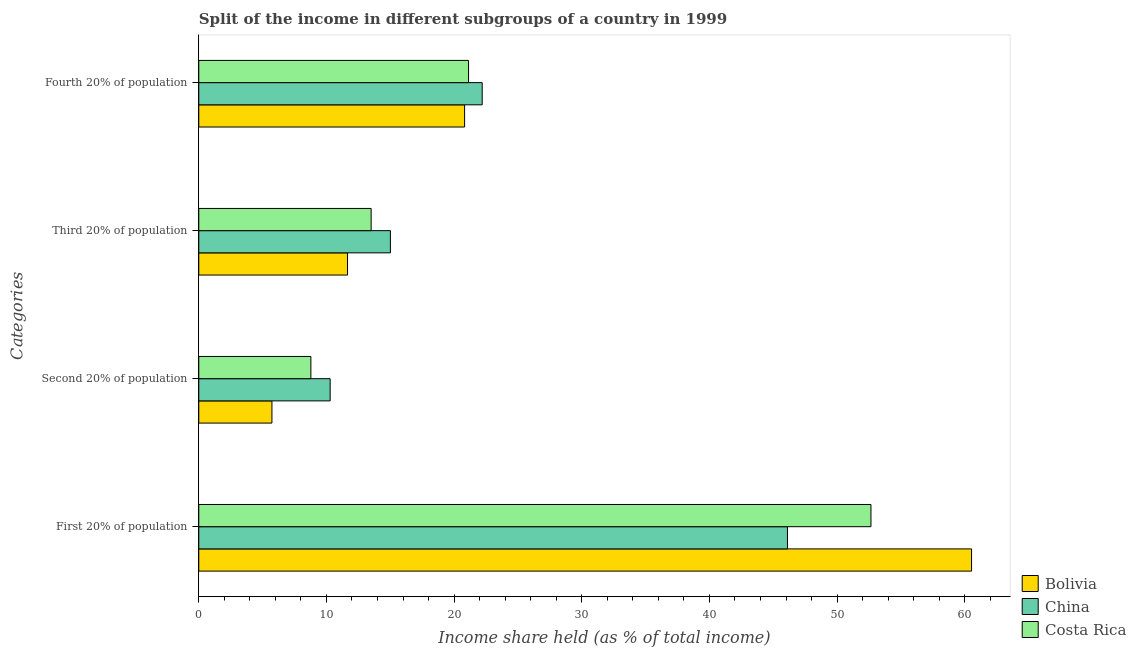How many groups of bars are there?
Keep it short and to the point. 4. Are the number of bars on each tick of the Y-axis equal?
Ensure brevity in your answer.  Yes. What is the label of the 1st group of bars from the top?
Provide a succinct answer. Fourth 20% of population. What is the share of the income held by second 20% of the population in Costa Rica?
Ensure brevity in your answer.  8.78. Across all countries, what is the maximum share of the income held by fourth 20% of the population?
Offer a very short reply. 22.2. Across all countries, what is the minimum share of the income held by fourth 20% of the population?
Your answer should be very brief. 20.82. In which country was the share of the income held by fourth 20% of the population minimum?
Ensure brevity in your answer.  Bolivia. What is the total share of the income held by fourth 20% of the population in the graph?
Provide a short and direct response. 64.15. What is the difference between the share of the income held by first 20% of the population in Costa Rica and that in China?
Your answer should be compact. 6.54. What is the difference between the share of the income held by fourth 20% of the population in Bolivia and the share of the income held by second 20% of the population in Costa Rica?
Provide a short and direct response. 12.04. What is the average share of the income held by first 20% of the population per country?
Offer a very short reply. 53.1. What is the difference between the share of the income held by fourth 20% of the population and share of the income held by second 20% of the population in Costa Rica?
Provide a succinct answer. 12.35. In how many countries, is the share of the income held by third 20% of the population greater than 42 %?
Keep it short and to the point. 0. What is the ratio of the share of the income held by fourth 20% of the population in Costa Rica to that in Bolivia?
Your response must be concise. 1.01. Is the share of the income held by fourth 20% of the population in Bolivia less than that in China?
Make the answer very short. Yes. What is the difference between the highest and the second highest share of the income held by second 20% of the population?
Ensure brevity in your answer.  1.51. What is the difference between the highest and the lowest share of the income held by first 20% of the population?
Offer a terse response. 14.42. Is the sum of the share of the income held by first 20% of the population in China and Costa Rica greater than the maximum share of the income held by fourth 20% of the population across all countries?
Ensure brevity in your answer.  Yes. Is it the case that in every country, the sum of the share of the income held by second 20% of the population and share of the income held by fourth 20% of the population is greater than the sum of share of the income held by first 20% of the population and share of the income held by third 20% of the population?
Give a very brief answer. No. Is it the case that in every country, the sum of the share of the income held by first 20% of the population and share of the income held by second 20% of the population is greater than the share of the income held by third 20% of the population?
Ensure brevity in your answer.  Yes. How many bars are there?
Give a very brief answer. 12. Are all the bars in the graph horizontal?
Your answer should be compact. Yes. How many countries are there in the graph?
Provide a succinct answer. 3. What is the difference between two consecutive major ticks on the X-axis?
Your response must be concise. 10. Are the values on the major ticks of X-axis written in scientific E-notation?
Provide a short and direct response. No. Where does the legend appear in the graph?
Your answer should be very brief. Bottom right. How many legend labels are there?
Give a very brief answer. 3. How are the legend labels stacked?
Give a very brief answer. Vertical. What is the title of the graph?
Make the answer very short. Split of the income in different subgroups of a country in 1999. What is the label or title of the X-axis?
Offer a terse response. Income share held (as % of total income). What is the label or title of the Y-axis?
Make the answer very short. Categories. What is the Income share held (as % of total income) of Bolivia in First 20% of population?
Make the answer very short. 60.53. What is the Income share held (as % of total income) of China in First 20% of population?
Provide a short and direct response. 46.11. What is the Income share held (as % of total income) in Costa Rica in First 20% of population?
Offer a very short reply. 52.65. What is the Income share held (as % of total income) in Bolivia in Second 20% of population?
Offer a terse response. 5.73. What is the Income share held (as % of total income) in China in Second 20% of population?
Offer a very short reply. 10.29. What is the Income share held (as % of total income) in Costa Rica in Second 20% of population?
Give a very brief answer. 8.78. What is the Income share held (as % of total income) of Bolivia in Third 20% of population?
Your response must be concise. 11.65. What is the Income share held (as % of total income) in China in Third 20% of population?
Ensure brevity in your answer.  15.01. What is the Income share held (as % of total income) in Costa Rica in Third 20% of population?
Offer a terse response. 13.5. What is the Income share held (as % of total income) in Bolivia in Fourth 20% of population?
Your response must be concise. 20.82. What is the Income share held (as % of total income) in China in Fourth 20% of population?
Your response must be concise. 22.2. What is the Income share held (as % of total income) in Costa Rica in Fourth 20% of population?
Your answer should be very brief. 21.13. Across all Categories, what is the maximum Income share held (as % of total income) of Bolivia?
Offer a very short reply. 60.53. Across all Categories, what is the maximum Income share held (as % of total income) of China?
Offer a terse response. 46.11. Across all Categories, what is the maximum Income share held (as % of total income) of Costa Rica?
Give a very brief answer. 52.65. Across all Categories, what is the minimum Income share held (as % of total income) of Bolivia?
Provide a succinct answer. 5.73. Across all Categories, what is the minimum Income share held (as % of total income) of China?
Provide a short and direct response. 10.29. Across all Categories, what is the minimum Income share held (as % of total income) of Costa Rica?
Your answer should be compact. 8.78. What is the total Income share held (as % of total income) of Bolivia in the graph?
Provide a short and direct response. 98.73. What is the total Income share held (as % of total income) of China in the graph?
Offer a terse response. 93.61. What is the total Income share held (as % of total income) of Costa Rica in the graph?
Make the answer very short. 96.06. What is the difference between the Income share held (as % of total income) in Bolivia in First 20% of population and that in Second 20% of population?
Your answer should be compact. 54.8. What is the difference between the Income share held (as % of total income) in China in First 20% of population and that in Second 20% of population?
Provide a short and direct response. 35.82. What is the difference between the Income share held (as % of total income) in Costa Rica in First 20% of population and that in Second 20% of population?
Make the answer very short. 43.87. What is the difference between the Income share held (as % of total income) of Bolivia in First 20% of population and that in Third 20% of population?
Keep it short and to the point. 48.88. What is the difference between the Income share held (as % of total income) in China in First 20% of population and that in Third 20% of population?
Provide a short and direct response. 31.1. What is the difference between the Income share held (as % of total income) in Costa Rica in First 20% of population and that in Third 20% of population?
Your answer should be very brief. 39.15. What is the difference between the Income share held (as % of total income) in Bolivia in First 20% of population and that in Fourth 20% of population?
Offer a terse response. 39.71. What is the difference between the Income share held (as % of total income) of China in First 20% of population and that in Fourth 20% of population?
Give a very brief answer. 23.91. What is the difference between the Income share held (as % of total income) of Costa Rica in First 20% of population and that in Fourth 20% of population?
Ensure brevity in your answer.  31.52. What is the difference between the Income share held (as % of total income) of Bolivia in Second 20% of population and that in Third 20% of population?
Keep it short and to the point. -5.92. What is the difference between the Income share held (as % of total income) in China in Second 20% of population and that in Third 20% of population?
Give a very brief answer. -4.72. What is the difference between the Income share held (as % of total income) of Costa Rica in Second 20% of population and that in Third 20% of population?
Keep it short and to the point. -4.72. What is the difference between the Income share held (as % of total income) in Bolivia in Second 20% of population and that in Fourth 20% of population?
Offer a very short reply. -15.09. What is the difference between the Income share held (as % of total income) in China in Second 20% of population and that in Fourth 20% of population?
Ensure brevity in your answer.  -11.91. What is the difference between the Income share held (as % of total income) in Costa Rica in Second 20% of population and that in Fourth 20% of population?
Your response must be concise. -12.35. What is the difference between the Income share held (as % of total income) in Bolivia in Third 20% of population and that in Fourth 20% of population?
Your answer should be compact. -9.17. What is the difference between the Income share held (as % of total income) in China in Third 20% of population and that in Fourth 20% of population?
Offer a very short reply. -7.19. What is the difference between the Income share held (as % of total income) in Costa Rica in Third 20% of population and that in Fourth 20% of population?
Give a very brief answer. -7.63. What is the difference between the Income share held (as % of total income) of Bolivia in First 20% of population and the Income share held (as % of total income) of China in Second 20% of population?
Your answer should be compact. 50.24. What is the difference between the Income share held (as % of total income) of Bolivia in First 20% of population and the Income share held (as % of total income) of Costa Rica in Second 20% of population?
Provide a short and direct response. 51.75. What is the difference between the Income share held (as % of total income) of China in First 20% of population and the Income share held (as % of total income) of Costa Rica in Second 20% of population?
Offer a very short reply. 37.33. What is the difference between the Income share held (as % of total income) in Bolivia in First 20% of population and the Income share held (as % of total income) in China in Third 20% of population?
Give a very brief answer. 45.52. What is the difference between the Income share held (as % of total income) of Bolivia in First 20% of population and the Income share held (as % of total income) of Costa Rica in Third 20% of population?
Offer a terse response. 47.03. What is the difference between the Income share held (as % of total income) in China in First 20% of population and the Income share held (as % of total income) in Costa Rica in Third 20% of population?
Give a very brief answer. 32.61. What is the difference between the Income share held (as % of total income) of Bolivia in First 20% of population and the Income share held (as % of total income) of China in Fourth 20% of population?
Offer a terse response. 38.33. What is the difference between the Income share held (as % of total income) in Bolivia in First 20% of population and the Income share held (as % of total income) in Costa Rica in Fourth 20% of population?
Your response must be concise. 39.4. What is the difference between the Income share held (as % of total income) of China in First 20% of population and the Income share held (as % of total income) of Costa Rica in Fourth 20% of population?
Provide a succinct answer. 24.98. What is the difference between the Income share held (as % of total income) of Bolivia in Second 20% of population and the Income share held (as % of total income) of China in Third 20% of population?
Offer a very short reply. -9.28. What is the difference between the Income share held (as % of total income) of Bolivia in Second 20% of population and the Income share held (as % of total income) of Costa Rica in Third 20% of population?
Give a very brief answer. -7.77. What is the difference between the Income share held (as % of total income) in China in Second 20% of population and the Income share held (as % of total income) in Costa Rica in Third 20% of population?
Provide a short and direct response. -3.21. What is the difference between the Income share held (as % of total income) of Bolivia in Second 20% of population and the Income share held (as % of total income) of China in Fourth 20% of population?
Your answer should be compact. -16.47. What is the difference between the Income share held (as % of total income) in Bolivia in Second 20% of population and the Income share held (as % of total income) in Costa Rica in Fourth 20% of population?
Your answer should be compact. -15.4. What is the difference between the Income share held (as % of total income) in China in Second 20% of population and the Income share held (as % of total income) in Costa Rica in Fourth 20% of population?
Your answer should be very brief. -10.84. What is the difference between the Income share held (as % of total income) of Bolivia in Third 20% of population and the Income share held (as % of total income) of China in Fourth 20% of population?
Provide a short and direct response. -10.55. What is the difference between the Income share held (as % of total income) of Bolivia in Third 20% of population and the Income share held (as % of total income) of Costa Rica in Fourth 20% of population?
Give a very brief answer. -9.48. What is the difference between the Income share held (as % of total income) in China in Third 20% of population and the Income share held (as % of total income) in Costa Rica in Fourth 20% of population?
Provide a succinct answer. -6.12. What is the average Income share held (as % of total income) of Bolivia per Categories?
Your response must be concise. 24.68. What is the average Income share held (as % of total income) in China per Categories?
Your response must be concise. 23.4. What is the average Income share held (as % of total income) of Costa Rica per Categories?
Make the answer very short. 24.02. What is the difference between the Income share held (as % of total income) of Bolivia and Income share held (as % of total income) of China in First 20% of population?
Your answer should be compact. 14.42. What is the difference between the Income share held (as % of total income) in Bolivia and Income share held (as % of total income) in Costa Rica in First 20% of population?
Your answer should be very brief. 7.88. What is the difference between the Income share held (as % of total income) in China and Income share held (as % of total income) in Costa Rica in First 20% of population?
Ensure brevity in your answer.  -6.54. What is the difference between the Income share held (as % of total income) of Bolivia and Income share held (as % of total income) of China in Second 20% of population?
Give a very brief answer. -4.56. What is the difference between the Income share held (as % of total income) of Bolivia and Income share held (as % of total income) of Costa Rica in Second 20% of population?
Offer a terse response. -3.05. What is the difference between the Income share held (as % of total income) of China and Income share held (as % of total income) of Costa Rica in Second 20% of population?
Offer a very short reply. 1.51. What is the difference between the Income share held (as % of total income) of Bolivia and Income share held (as % of total income) of China in Third 20% of population?
Provide a short and direct response. -3.36. What is the difference between the Income share held (as % of total income) of Bolivia and Income share held (as % of total income) of Costa Rica in Third 20% of population?
Your answer should be very brief. -1.85. What is the difference between the Income share held (as % of total income) of China and Income share held (as % of total income) of Costa Rica in Third 20% of population?
Your answer should be compact. 1.51. What is the difference between the Income share held (as % of total income) of Bolivia and Income share held (as % of total income) of China in Fourth 20% of population?
Make the answer very short. -1.38. What is the difference between the Income share held (as % of total income) in Bolivia and Income share held (as % of total income) in Costa Rica in Fourth 20% of population?
Your answer should be very brief. -0.31. What is the difference between the Income share held (as % of total income) of China and Income share held (as % of total income) of Costa Rica in Fourth 20% of population?
Offer a very short reply. 1.07. What is the ratio of the Income share held (as % of total income) of Bolivia in First 20% of population to that in Second 20% of population?
Ensure brevity in your answer.  10.56. What is the ratio of the Income share held (as % of total income) in China in First 20% of population to that in Second 20% of population?
Give a very brief answer. 4.48. What is the ratio of the Income share held (as % of total income) of Costa Rica in First 20% of population to that in Second 20% of population?
Give a very brief answer. 6. What is the ratio of the Income share held (as % of total income) of Bolivia in First 20% of population to that in Third 20% of population?
Offer a terse response. 5.2. What is the ratio of the Income share held (as % of total income) in China in First 20% of population to that in Third 20% of population?
Ensure brevity in your answer.  3.07. What is the ratio of the Income share held (as % of total income) in Costa Rica in First 20% of population to that in Third 20% of population?
Your answer should be compact. 3.9. What is the ratio of the Income share held (as % of total income) in Bolivia in First 20% of population to that in Fourth 20% of population?
Your answer should be compact. 2.91. What is the ratio of the Income share held (as % of total income) in China in First 20% of population to that in Fourth 20% of population?
Offer a very short reply. 2.08. What is the ratio of the Income share held (as % of total income) of Costa Rica in First 20% of population to that in Fourth 20% of population?
Provide a short and direct response. 2.49. What is the ratio of the Income share held (as % of total income) in Bolivia in Second 20% of population to that in Third 20% of population?
Give a very brief answer. 0.49. What is the ratio of the Income share held (as % of total income) of China in Second 20% of population to that in Third 20% of population?
Provide a short and direct response. 0.69. What is the ratio of the Income share held (as % of total income) in Costa Rica in Second 20% of population to that in Third 20% of population?
Provide a succinct answer. 0.65. What is the ratio of the Income share held (as % of total income) in Bolivia in Second 20% of population to that in Fourth 20% of population?
Make the answer very short. 0.28. What is the ratio of the Income share held (as % of total income) of China in Second 20% of population to that in Fourth 20% of population?
Your response must be concise. 0.46. What is the ratio of the Income share held (as % of total income) of Costa Rica in Second 20% of population to that in Fourth 20% of population?
Make the answer very short. 0.42. What is the ratio of the Income share held (as % of total income) in Bolivia in Third 20% of population to that in Fourth 20% of population?
Provide a succinct answer. 0.56. What is the ratio of the Income share held (as % of total income) of China in Third 20% of population to that in Fourth 20% of population?
Give a very brief answer. 0.68. What is the ratio of the Income share held (as % of total income) of Costa Rica in Third 20% of population to that in Fourth 20% of population?
Ensure brevity in your answer.  0.64. What is the difference between the highest and the second highest Income share held (as % of total income) of Bolivia?
Provide a succinct answer. 39.71. What is the difference between the highest and the second highest Income share held (as % of total income) of China?
Offer a very short reply. 23.91. What is the difference between the highest and the second highest Income share held (as % of total income) of Costa Rica?
Your response must be concise. 31.52. What is the difference between the highest and the lowest Income share held (as % of total income) of Bolivia?
Offer a terse response. 54.8. What is the difference between the highest and the lowest Income share held (as % of total income) in China?
Provide a short and direct response. 35.82. What is the difference between the highest and the lowest Income share held (as % of total income) in Costa Rica?
Make the answer very short. 43.87. 